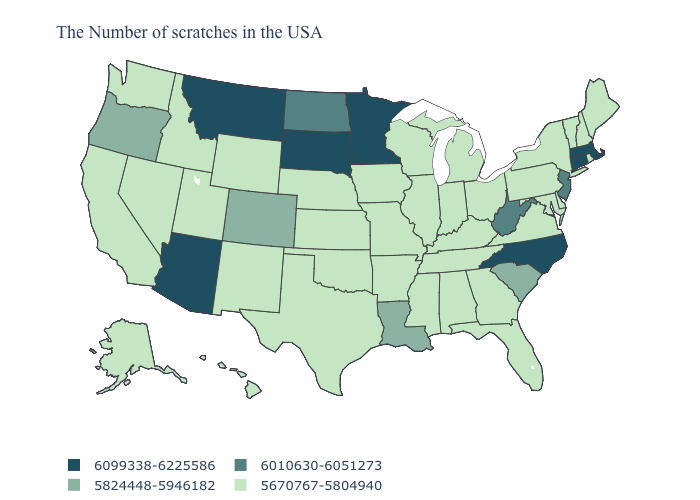Name the states that have a value in the range 6010630-6051273?
Answer briefly. New Jersey, West Virginia, North Dakota. Is the legend a continuous bar?
Concise answer only. No. Among the states that border Florida , which have the highest value?
Quick response, please. Georgia, Alabama. What is the value of Georgia?
Answer briefly. 5670767-5804940. Name the states that have a value in the range 5824448-5946182?
Answer briefly. South Carolina, Louisiana, Colorado, Oregon. Does the first symbol in the legend represent the smallest category?
Short answer required. No. Which states have the highest value in the USA?
Short answer required. Massachusetts, Connecticut, North Carolina, Minnesota, South Dakota, Montana, Arizona. Name the states that have a value in the range 6099338-6225586?
Short answer required. Massachusetts, Connecticut, North Carolina, Minnesota, South Dakota, Montana, Arizona. What is the value of New York?
Write a very short answer. 5670767-5804940. How many symbols are there in the legend?
Be succinct. 4. Does Massachusetts have the highest value in the USA?
Be succinct. Yes. Which states have the highest value in the USA?
Concise answer only. Massachusetts, Connecticut, North Carolina, Minnesota, South Dakota, Montana, Arizona. Which states have the lowest value in the USA?
Write a very short answer. Maine, Rhode Island, New Hampshire, Vermont, New York, Delaware, Maryland, Pennsylvania, Virginia, Ohio, Florida, Georgia, Michigan, Kentucky, Indiana, Alabama, Tennessee, Wisconsin, Illinois, Mississippi, Missouri, Arkansas, Iowa, Kansas, Nebraska, Oklahoma, Texas, Wyoming, New Mexico, Utah, Idaho, Nevada, California, Washington, Alaska, Hawaii. Does New Hampshire have the highest value in the Northeast?
Quick response, please. No. Does the map have missing data?
Keep it brief. No. 